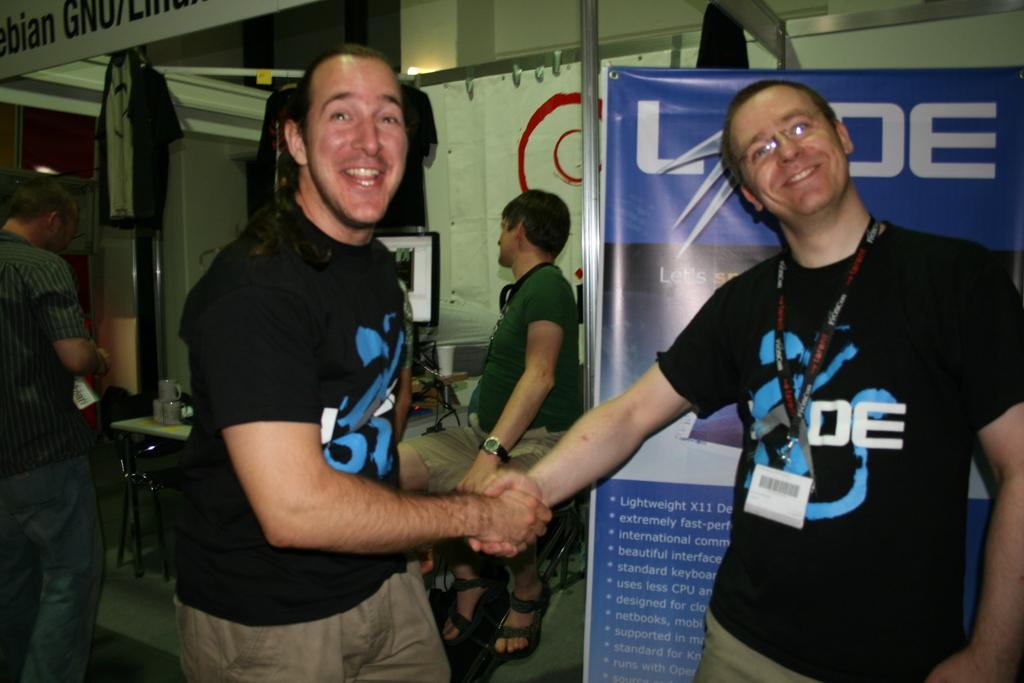How many men are present in the image? There are four men in the image. What are the positions of the men in the image? Three men are standing on the floor, and one man is sitting on a chair. What type of objects can be seen in the image related to beverages? There are cups and a glass visible in the image. What electronic device is present in the image? There is a monitor in the image. What type of signage is present in the image? There is a banner in the image. What can be seen in the background of the image? There are rods and cloth visible in the background. What type of reaction can be seen on the faces of the men in the image? There is no indication of any specific reactions on the faces of the men in the image. What type of journey are the men embarking on in the image? There is no indication of any journey in the image; the men are simply standing or sitting. 